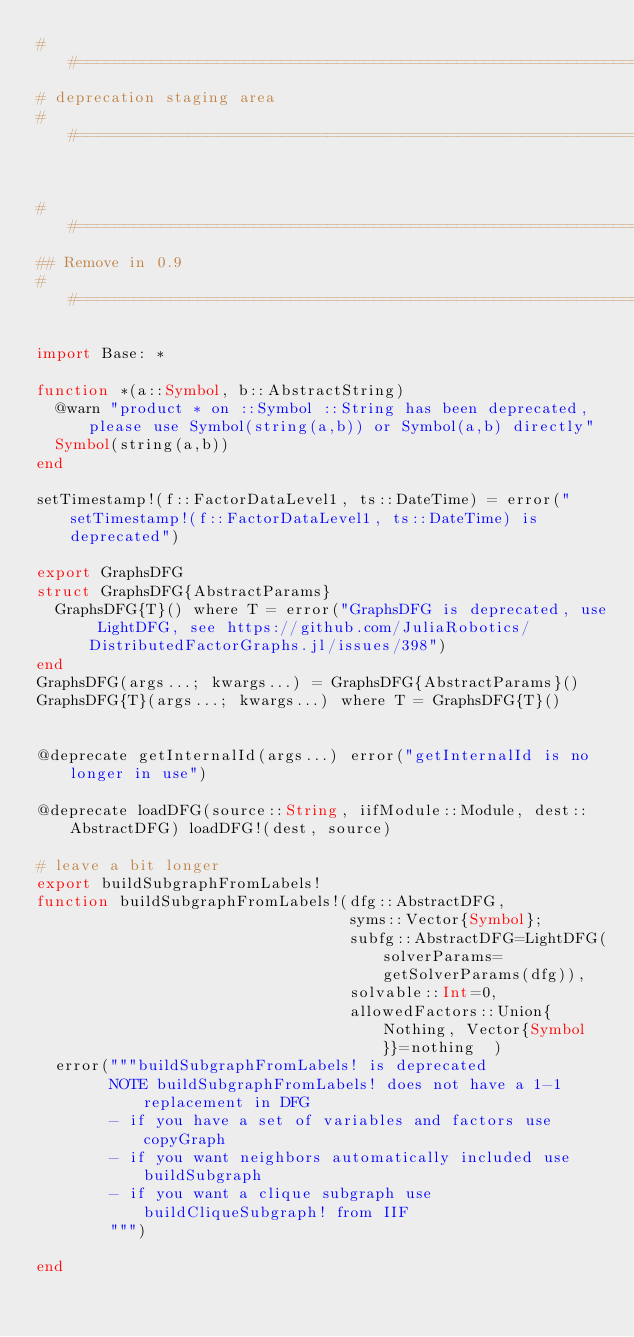Convert code to text. <code><loc_0><loc_0><loc_500><loc_500><_Julia_>##==============================================================================
# deprecation staging area
##==============================================================================


##==============================================================================
## Remove in 0.9
##==============================================================================

import Base: *

function *(a::Symbol, b::AbstractString)
  @warn "product * on ::Symbol ::String has been deprecated, please use Symbol(string(a,b)) or Symbol(a,b) directly"
  Symbol(string(a,b))
end

setTimestamp!(f::FactorDataLevel1, ts::DateTime) = error("setTimestamp!(f::FactorDataLevel1, ts::DateTime) is deprecated")

export GraphsDFG
struct GraphsDFG{AbstractParams}
  GraphsDFG{T}() where T = error("GraphsDFG is deprecated, use LightDFG, see https://github.com/JuliaRobotics/DistributedFactorGraphs.jl/issues/398")
end
GraphsDFG(args...; kwargs...) = GraphsDFG{AbstractParams}()
GraphsDFG{T}(args...; kwargs...) where T = GraphsDFG{T}()


@deprecate getInternalId(args...) error("getInternalId is no longer in use")

@deprecate loadDFG(source::String, iifModule::Module, dest::AbstractDFG) loadDFG!(dest, source)

# leave a bit longer
export buildSubgraphFromLabels!
function buildSubgraphFromLabels!(dfg::AbstractDFG,
                                  syms::Vector{Symbol};
                                  subfg::AbstractDFG=LightDFG(solverParams=getSolverParams(dfg)),
                                  solvable::Int=0,
                                  allowedFactors::Union{Nothing, Vector{Symbol}}=nothing  )
  error("""buildSubgraphFromLabels! is deprecated
        NOTE buildSubgraphFromLabels! does not have a 1-1 replacement in DFG
        - if you have a set of variables and factors use copyGraph
        - if you want neighbors automatically included use buildSubgraph
        - if you want a clique subgraph use buildCliqueSubgraph! from IIF
        """)

end
</code> 